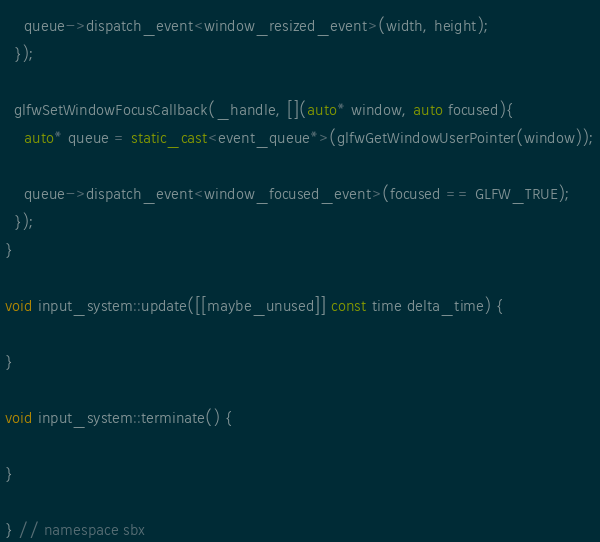<code> <loc_0><loc_0><loc_500><loc_500><_C++_>    queue->dispatch_event<window_resized_event>(width, height);
  });

  glfwSetWindowFocusCallback(_handle, [](auto* window, auto focused){
    auto* queue = static_cast<event_queue*>(glfwGetWindowUserPointer(window));

    queue->dispatch_event<window_focused_event>(focused == GLFW_TRUE);
  });
}

void input_system::update([[maybe_unused]] const time delta_time) {

}

void input_system::terminate() {

}

} // namespace sbx
</code> 